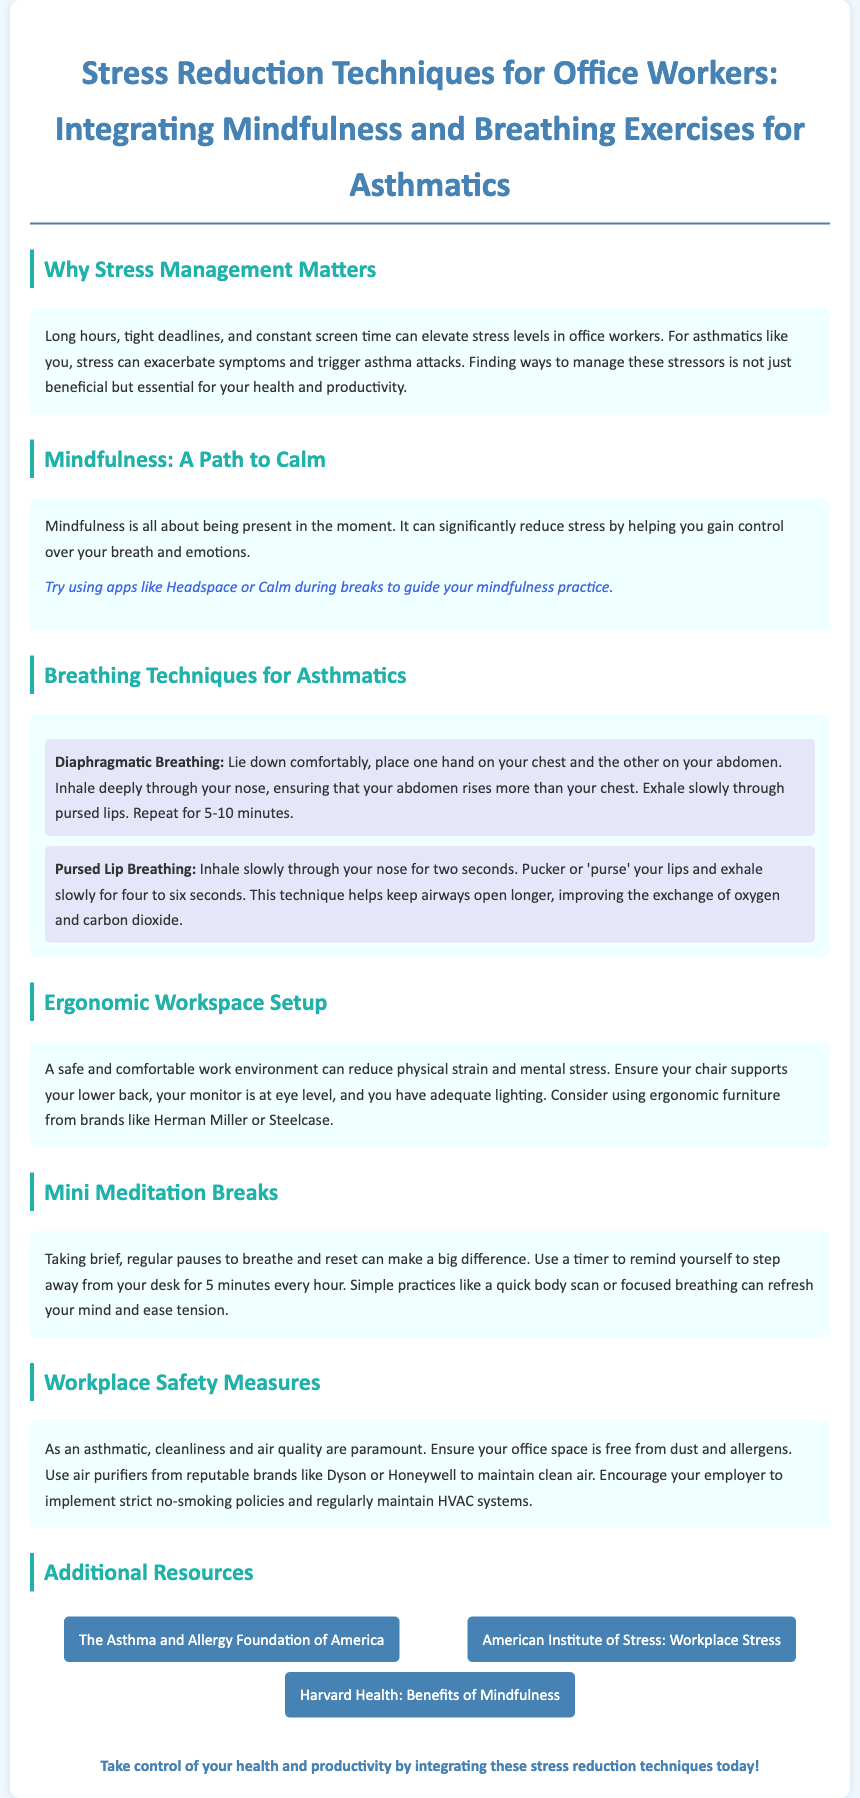What are the two breathing techniques mentioned? The document lists "Diaphragmatic Breathing" and "Pursed Lip Breathing" as the two breathing techniques.
Answer: Diaphragmatic Breathing, Pursed Lip Breathing How long should mini meditation breaks last? The document suggests using a timer to remind yourself to step away for brief pauses of 5 minutes every hour.
Answer: 5 minutes What is a key aspect of a safe workspace for asthmatics? The document emphasizes cleanliness and air quality as paramount safety measures for asthmatics.
Answer: Cleanliness and air quality What is the recommended frequency for taking breaks? The document advises taking brief breaks every hour to help manage stress.
Answer: Every hour Which brands are suggested for ergonomic furniture? The document mentions brands such as Herman Miller and Steelcase for ergonomic furniture.
Answer: Herman Miller, Steelcase What is the purpose of using mindfulness apps? The document explains that apps like Headspace or Calm can guide mindfulness practice during breaks, reducing stress.
Answer: Reduce stress How many minutes should diaphragmatic breathing be practiced? The document states to repeat diaphragmatic breathing for 5-10 minutes.
Answer: 5-10 minutes What foundation is referenced for asthma and allergy information? The document includes a resource link to the Asthma and Allergy Foundation of America.
Answer: The Asthma and Allergy Foundation of America What color scheme is used for the document's design? The document uses a soothing color scheme with shades of blue and light colors to promote a calm reading environment.
Answer: Shades of blue and light colors 